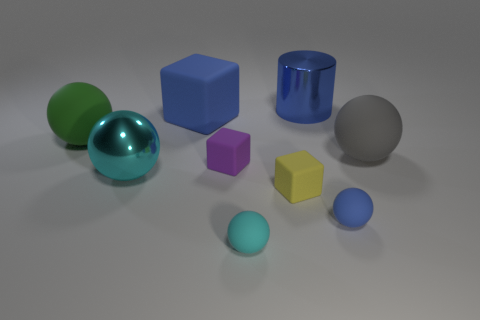There is a big thing that is the same color as the big rubber block; what is its material?
Give a very brief answer. Metal. Is there anything else that has the same size as the gray rubber object?
Offer a very short reply. Yes. How many small objects are either brown cubes or blue rubber objects?
Your answer should be very brief. 1. Are there fewer small yellow blocks than big red shiny cylinders?
Provide a short and direct response. No. The other tiny thing that is the same shape as the purple object is what color?
Offer a terse response. Yellow. Is there anything else that has the same shape as the green rubber thing?
Offer a very short reply. Yes. Is the number of cyan matte cylinders greater than the number of big balls?
Ensure brevity in your answer.  No. How many other things are made of the same material as the gray thing?
Make the answer very short. 6. The yellow object that is left of the small thing that is on the right side of the matte cube that is on the right side of the purple rubber object is what shape?
Provide a succinct answer. Cube. Are there fewer cyan matte spheres behind the small blue sphere than tiny purple cubes behind the purple matte thing?
Your answer should be very brief. No. 